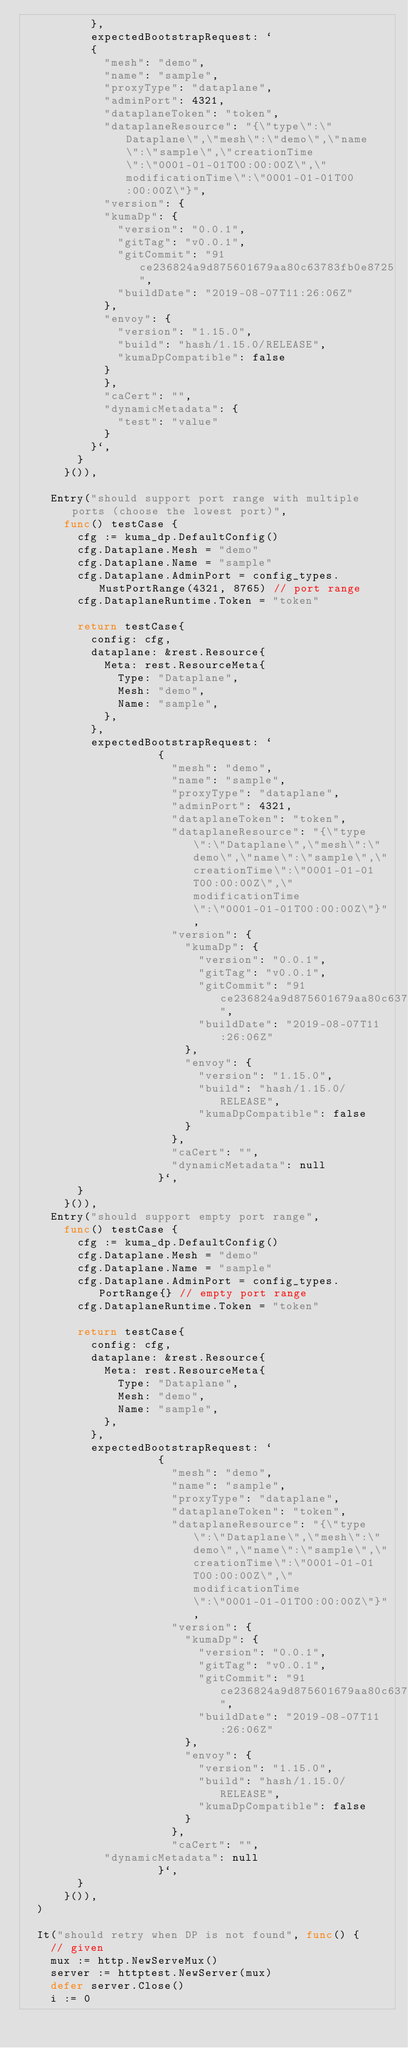<code> <loc_0><loc_0><loc_500><loc_500><_Go_>					},
					expectedBootstrapRequest: `
					{
					  "mesh": "demo",
					  "name": "sample",
					  "proxyType": "dataplane",
					  "adminPort": 4321,
					  "dataplaneToken": "token",
					  "dataplaneResource": "{\"type\":\"Dataplane\",\"mesh\":\"demo\",\"name\":\"sample\",\"creationTime\":\"0001-01-01T00:00:00Z\",\"modificationTime\":\"0001-01-01T00:00:00Z\"}",
					  "version": {
						"kumaDp": {
						  "version": "0.0.1",
						  "gitTag": "v0.0.1",
						  "gitCommit": "91ce236824a9d875601679aa80c63783fb0e8725",
						  "buildDate": "2019-08-07T11:26:06Z"
						},
						"envoy": {
						  "version": "1.15.0",
						  "build": "hash/1.15.0/RELEASE",
						  "kumaDpCompatible": false
						}
					  },
					  "caCert": "",
					  "dynamicMetadata": {
					    "test": "value"
					  }
					}`,
				}
			}()),

		Entry("should support port range with multiple ports (choose the lowest port)",
			func() testCase {
				cfg := kuma_dp.DefaultConfig()
				cfg.Dataplane.Mesh = "demo"
				cfg.Dataplane.Name = "sample"
				cfg.Dataplane.AdminPort = config_types.MustPortRange(4321, 8765) // port range
				cfg.DataplaneRuntime.Token = "token"

				return testCase{
					config: cfg,
					dataplane: &rest.Resource{
						Meta: rest.ResourceMeta{
							Type: "Dataplane",
							Mesh: "demo",
							Name: "sample",
						},
					},
					expectedBootstrapRequest: `
                    {
                      "mesh": "demo",
                      "name": "sample",
                      "proxyType": "dataplane",
                      "adminPort": 4321,
                      "dataplaneToken": "token",
                      "dataplaneResource": "{\"type\":\"Dataplane\",\"mesh\":\"demo\",\"name\":\"sample\",\"creationTime\":\"0001-01-01T00:00:00Z\",\"modificationTime\":\"0001-01-01T00:00:00Z\"}",
                      "version": {
                        "kumaDp": {
                          "version": "0.0.1",
                          "gitTag": "v0.0.1",
                          "gitCommit": "91ce236824a9d875601679aa80c63783fb0e8725",
                          "buildDate": "2019-08-07T11:26:06Z"
                        },
                        "envoy": {
                          "version": "1.15.0",
                          "build": "hash/1.15.0/RELEASE",
                          "kumaDpCompatible": false
                        }
                      },
                      "caCert": "",
                      "dynamicMetadata": null
                    }`,
				}
			}()),
		Entry("should support empty port range",
			func() testCase {
				cfg := kuma_dp.DefaultConfig()
				cfg.Dataplane.Mesh = "demo"
				cfg.Dataplane.Name = "sample"
				cfg.Dataplane.AdminPort = config_types.PortRange{} // empty port range
				cfg.DataplaneRuntime.Token = "token"

				return testCase{
					config: cfg,
					dataplane: &rest.Resource{
						Meta: rest.ResourceMeta{
							Type: "Dataplane",
							Mesh: "demo",
							Name: "sample",
						},
					},
					expectedBootstrapRequest: `
                    {
                      "mesh": "demo",
                      "name": "sample",
                      "proxyType": "dataplane",
                      "dataplaneToken": "token",
                      "dataplaneResource": "{\"type\":\"Dataplane\",\"mesh\":\"demo\",\"name\":\"sample\",\"creationTime\":\"0001-01-01T00:00:00Z\",\"modificationTime\":\"0001-01-01T00:00:00Z\"}",
                      "version": {
                        "kumaDp": {
                          "version": "0.0.1",
                          "gitTag": "v0.0.1",
                          "gitCommit": "91ce236824a9d875601679aa80c63783fb0e8725",
                          "buildDate": "2019-08-07T11:26:06Z"
                        },
                        "envoy": {
                          "version": "1.15.0",
                          "build": "hash/1.15.0/RELEASE",
                          "kumaDpCompatible": false
                        }
                      },
                      "caCert": "",
					  "dynamicMetadata": null
                    }`,
				}
			}()),
	)

	It("should retry when DP is not found", func() {
		// given
		mux := http.NewServeMux()
		server := httptest.NewServer(mux)
		defer server.Close()
		i := 0</code> 